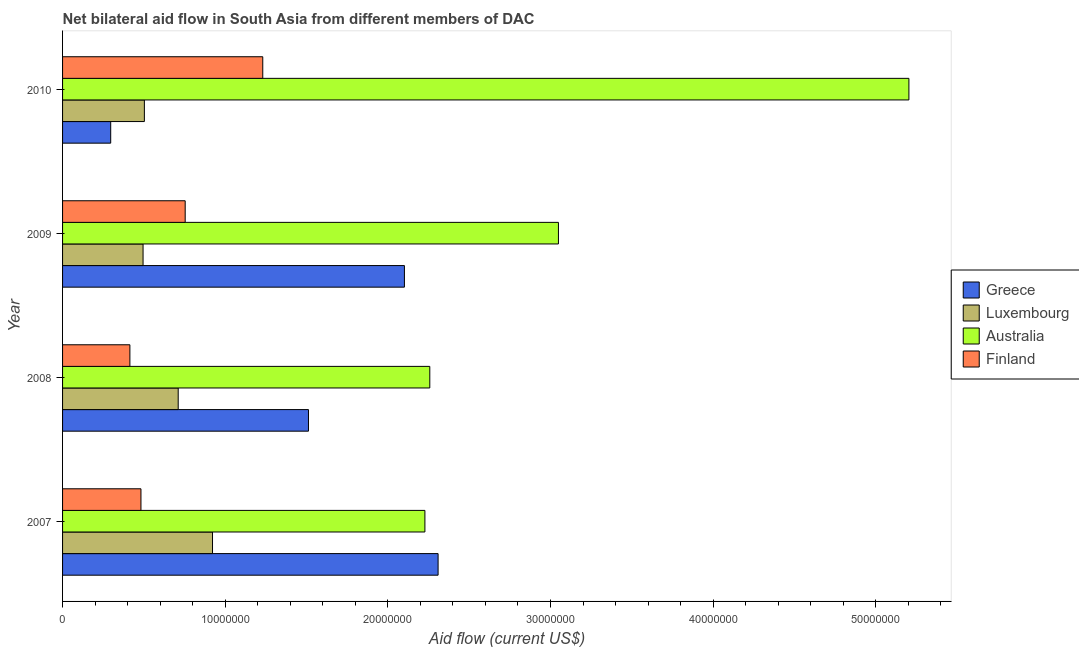How many different coloured bars are there?
Make the answer very short. 4. Are the number of bars per tick equal to the number of legend labels?
Give a very brief answer. Yes. Are the number of bars on each tick of the Y-axis equal?
Ensure brevity in your answer.  Yes. How many bars are there on the 4th tick from the top?
Keep it short and to the point. 4. How many bars are there on the 3rd tick from the bottom?
Give a very brief answer. 4. What is the amount of aid given by australia in 2009?
Provide a short and direct response. 3.05e+07. Across all years, what is the maximum amount of aid given by australia?
Provide a succinct answer. 5.20e+07. Across all years, what is the minimum amount of aid given by finland?
Provide a succinct answer. 4.14e+06. In which year was the amount of aid given by finland minimum?
Provide a succinct answer. 2008. What is the total amount of aid given by finland in the graph?
Offer a very short reply. 2.88e+07. What is the difference between the amount of aid given by greece in 2007 and that in 2009?
Your answer should be compact. 2.07e+06. What is the difference between the amount of aid given by luxembourg in 2010 and the amount of aid given by greece in 2008?
Make the answer very short. -1.01e+07. What is the average amount of aid given by luxembourg per year?
Provide a succinct answer. 6.58e+06. In the year 2007, what is the difference between the amount of aid given by luxembourg and amount of aid given by australia?
Make the answer very short. -1.31e+07. In how many years, is the amount of aid given by luxembourg greater than 20000000 US$?
Give a very brief answer. 0. What is the ratio of the amount of aid given by finland in 2008 to that in 2010?
Your answer should be compact. 0.34. Is the amount of aid given by australia in 2007 less than that in 2010?
Your answer should be very brief. Yes. Is the difference between the amount of aid given by luxembourg in 2008 and 2010 greater than the difference between the amount of aid given by greece in 2008 and 2010?
Provide a succinct answer. No. What is the difference between the highest and the second highest amount of aid given by finland?
Keep it short and to the point. 4.77e+06. What is the difference between the highest and the lowest amount of aid given by australia?
Your answer should be compact. 2.98e+07. In how many years, is the amount of aid given by australia greater than the average amount of aid given by australia taken over all years?
Your answer should be compact. 1. Is it the case that in every year, the sum of the amount of aid given by finland and amount of aid given by luxembourg is greater than the sum of amount of aid given by greece and amount of aid given by australia?
Make the answer very short. No. What does the 2nd bar from the bottom in 2010 represents?
Give a very brief answer. Luxembourg. How many bars are there?
Your response must be concise. 16. Are the values on the major ticks of X-axis written in scientific E-notation?
Your answer should be very brief. No. Does the graph contain any zero values?
Keep it short and to the point. No. Where does the legend appear in the graph?
Ensure brevity in your answer.  Center right. How many legend labels are there?
Your answer should be very brief. 4. How are the legend labels stacked?
Offer a terse response. Vertical. What is the title of the graph?
Offer a very short reply. Net bilateral aid flow in South Asia from different members of DAC. Does "Social Awareness" appear as one of the legend labels in the graph?
Give a very brief answer. No. What is the label or title of the Y-axis?
Your answer should be compact. Year. What is the Aid flow (current US$) of Greece in 2007?
Your answer should be very brief. 2.31e+07. What is the Aid flow (current US$) of Luxembourg in 2007?
Keep it short and to the point. 9.22e+06. What is the Aid flow (current US$) of Australia in 2007?
Offer a terse response. 2.23e+07. What is the Aid flow (current US$) of Finland in 2007?
Your response must be concise. 4.82e+06. What is the Aid flow (current US$) in Greece in 2008?
Your answer should be very brief. 1.51e+07. What is the Aid flow (current US$) in Luxembourg in 2008?
Your answer should be very brief. 7.11e+06. What is the Aid flow (current US$) in Australia in 2008?
Your answer should be very brief. 2.26e+07. What is the Aid flow (current US$) of Finland in 2008?
Give a very brief answer. 4.14e+06. What is the Aid flow (current US$) in Greece in 2009?
Keep it short and to the point. 2.10e+07. What is the Aid flow (current US$) of Luxembourg in 2009?
Make the answer very short. 4.95e+06. What is the Aid flow (current US$) of Australia in 2009?
Ensure brevity in your answer.  3.05e+07. What is the Aid flow (current US$) in Finland in 2009?
Keep it short and to the point. 7.54e+06. What is the Aid flow (current US$) in Greece in 2010?
Keep it short and to the point. 2.96e+06. What is the Aid flow (current US$) in Luxembourg in 2010?
Offer a very short reply. 5.03e+06. What is the Aid flow (current US$) in Australia in 2010?
Your answer should be very brief. 5.20e+07. What is the Aid flow (current US$) in Finland in 2010?
Give a very brief answer. 1.23e+07. Across all years, what is the maximum Aid flow (current US$) in Greece?
Make the answer very short. 2.31e+07. Across all years, what is the maximum Aid flow (current US$) of Luxembourg?
Keep it short and to the point. 9.22e+06. Across all years, what is the maximum Aid flow (current US$) in Australia?
Offer a terse response. 5.20e+07. Across all years, what is the maximum Aid flow (current US$) of Finland?
Ensure brevity in your answer.  1.23e+07. Across all years, what is the minimum Aid flow (current US$) in Greece?
Your answer should be very brief. 2.96e+06. Across all years, what is the minimum Aid flow (current US$) in Luxembourg?
Ensure brevity in your answer.  4.95e+06. Across all years, what is the minimum Aid flow (current US$) in Australia?
Your response must be concise. 2.23e+07. Across all years, what is the minimum Aid flow (current US$) in Finland?
Your answer should be compact. 4.14e+06. What is the total Aid flow (current US$) in Greece in the graph?
Keep it short and to the point. 6.22e+07. What is the total Aid flow (current US$) of Luxembourg in the graph?
Your answer should be very brief. 2.63e+07. What is the total Aid flow (current US$) in Australia in the graph?
Your answer should be compact. 1.27e+08. What is the total Aid flow (current US$) in Finland in the graph?
Provide a short and direct response. 2.88e+07. What is the difference between the Aid flow (current US$) in Greece in 2007 and that in 2008?
Ensure brevity in your answer.  7.97e+06. What is the difference between the Aid flow (current US$) of Luxembourg in 2007 and that in 2008?
Your response must be concise. 2.11e+06. What is the difference between the Aid flow (current US$) of Australia in 2007 and that in 2008?
Give a very brief answer. -3.00e+05. What is the difference between the Aid flow (current US$) in Finland in 2007 and that in 2008?
Make the answer very short. 6.80e+05. What is the difference between the Aid flow (current US$) in Greece in 2007 and that in 2009?
Make the answer very short. 2.07e+06. What is the difference between the Aid flow (current US$) of Luxembourg in 2007 and that in 2009?
Your answer should be very brief. 4.27e+06. What is the difference between the Aid flow (current US$) of Australia in 2007 and that in 2009?
Keep it short and to the point. -8.21e+06. What is the difference between the Aid flow (current US$) in Finland in 2007 and that in 2009?
Provide a short and direct response. -2.72e+06. What is the difference between the Aid flow (current US$) of Greece in 2007 and that in 2010?
Your response must be concise. 2.01e+07. What is the difference between the Aid flow (current US$) of Luxembourg in 2007 and that in 2010?
Your response must be concise. 4.19e+06. What is the difference between the Aid flow (current US$) of Australia in 2007 and that in 2010?
Provide a short and direct response. -2.98e+07. What is the difference between the Aid flow (current US$) of Finland in 2007 and that in 2010?
Your answer should be very brief. -7.49e+06. What is the difference between the Aid flow (current US$) of Greece in 2008 and that in 2009?
Your response must be concise. -5.90e+06. What is the difference between the Aid flow (current US$) of Luxembourg in 2008 and that in 2009?
Give a very brief answer. 2.16e+06. What is the difference between the Aid flow (current US$) in Australia in 2008 and that in 2009?
Offer a terse response. -7.91e+06. What is the difference between the Aid flow (current US$) of Finland in 2008 and that in 2009?
Keep it short and to the point. -3.40e+06. What is the difference between the Aid flow (current US$) of Greece in 2008 and that in 2010?
Offer a terse response. 1.22e+07. What is the difference between the Aid flow (current US$) in Luxembourg in 2008 and that in 2010?
Ensure brevity in your answer.  2.08e+06. What is the difference between the Aid flow (current US$) of Australia in 2008 and that in 2010?
Offer a very short reply. -2.95e+07. What is the difference between the Aid flow (current US$) of Finland in 2008 and that in 2010?
Your answer should be compact. -8.17e+06. What is the difference between the Aid flow (current US$) in Greece in 2009 and that in 2010?
Give a very brief answer. 1.81e+07. What is the difference between the Aid flow (current US$) of Australia in 2009 and that in 2010?
Your answer should be compact. -2.16e+07. What is the difference between the Aid flow (current US$) in Finland in 2009 and that in 2010?
Give a very brief answer. -4.77e+06. What is the difference between the Aid flow (current US$) in Greece in 2007 and the Aid flow (current US$) in Luxembourg in 2008?
Provide a short and direct response. 1.60e+07. What is the difference between the Aid flow (current US$) of Greece in 2007 and the Aid flow (current US$) of Australia in 2008?
Offer a very short reply. 5.10e+05. What is the difference between the Aid flow (current US$) in Greece in 2007 and the Aid flow (current US$) in Finland in 2008?
Keep it short and to the point. 1.90e+07. What is the difference between the Aid flow (current US$) in Luxembourg in 2007 and the Aid flow (current US$) in Australia in 2008?
Keep it short and to the point. -1.34e+07. What is the difference between the Aid flow (current US$) of Luxembourg in 2007 and the Aid flow (current US$) of Finland in 2008?
Make the answer very short. 5.08e+06. What is the difference between the Aid flow (current US$) in Australia in 2007 and the Aid flow (current US$) in Finland in 2008?
Your response must be concise. 1.81e+07. What is the difference between the Aid flow (current US$) in Greece in 2007 and the Aid flow (current US$) in Luxembourg in 2009?
Give a very brief answer. 1.81e+07. What is the difference between the Aid flow (current US$) of Greece in 2007 and the Aid flow (current US$) of Australia in 2009?
Give a very brief answer. -7.40e+06. What is the difference between the Aid flow (current US$) of Greece in 2007 and the Aid flow (current US$) of Finland in 2009?
Offer a very short reply. 1.56e+07. What is the difference between the Aid flow (current US$) of Luxembourg in 2007 and the Aid flow (current US$) of Australia in 2009?
Your answer should be very brief. -2.13e+07. What is the difference between the Aid flow (current US$) of Luxembourg in 2007 and the Aid flow (current US$) of Finland in 2009?
Your response must be concise. 1.68e+06. What is the difference between the Aid flow (current US$) in Australia in 2007 and the Aid flow (current US$) in Finland in 2009?
Your answer should be compact. 1.47e+07. What is the difference between the Aid flow (current US$) in Greece in 2007 and the Aid flow (current US$) in Luxembourg in 2010?
Give a very brief answer. 1.81e+07. What is the difference between the Aid flow (current US$) of Greece in 2007 and the Aid flow (current US$) of Australia in 2010?
Provide a short and direct response. -2.90e+07. What is the difference between the Aid flow (current US$) of Greece in 2007 and the Aid flow (current US$) of Finland in 2010?
Ensure brevity in your answer.  1.08e+07. What is the difference between the Aid flow (current US$) in Luxembourg in 2007 and the Aid flow (current US$) in Australia in 2010?
Provide a succinct answer. -4.28e+07. What is the difference between the Aid flow (current US$) of Luxembourg in 2007 and the Aid flow (current US$) of Finland in 2010?
Provide a succinct answer. -3.09e+06. What is the difference between the Aid flow (current US$) in Australia in 2007 and the Aid flow (current US$) in Finland in 2010?
Offer a terse response. 9.97e+06. What is the difference between the Aid flow (current US$) of Greece in 2008 and the Aid flow (current US$) of Luxembourg in 2009?
Keep it short and to the point. 1.02e+07. What is the difference between the Aid flow (current US$) in Greece in 2008 and the Aid flow (current US$) in Australia in 2009?
Offer a very short reply. -1.54e+07. What is the difference between the Aid flow (current US$) of Greece in 2008 and the Aid flow (current US$) of Finland in 2009?
Ensure brevity in your answer.  7.58e+06. What is the difference between the Aid flow (current US$) in Luxembourg in 2008 and the Aid flow (current US$) in Australia in 2009?
Ensure brevity in your answer.  -2.34e+07. What is the difference between the Aid flow (current US$) of Luxembourg in 2008 and the Aid flow (current US$) of Finland in 2009?
Give a very brief answer. -4.30e+05. What is the difference between the Aid flow (current US$) of Australia in 2008 and the Aid flow (current US$) of Finland in 2009?
Give a very brief answer. 1.50e+07. What is the difference between the Aid flow (current US$) of Greece in 2008 and the Aid flow (current US$) of Luxembourg in 2010?
Keep it short and to the point. 1.01e+07. What is the difference between the Aid flow (current US$) of Greece in 2008 and the Aid flow (current US$) of Australia in 2010?
Ensure brevity in your answer.  -3.69e+07. What is the difference between the Aid flow (current US$) in Greece in 2008 and the Aid flow (current US$) in Finland in 2010?
Offer a very short reply. 2.81e+06. What is the difference between the Aid flow (current US$) of Luxembourg in 2008 and the Aid flow (current US$) of Australia in 2010?
Give a very brief answer. -4.49e+07. What is the difference between the Aid flow (current US$) of Luxembourg in 2008 and the Aid flow (current US$) of Finland in 2010?
Your answer should be compact. -5.20e+06. What is the difference between the Aid flow (current US$) in Australia in 2008 and the Aid flow (current US$) in Finland in 2010?
Provide a succinct answer. 1.03e+07. What is the difference between the Aid flow (current US$) in Greece in 2009 and the Aid flow (current US$) in Luxembourg in 2010?
Provide a succinct answer. 1.60e+07. What is the difference between the Aid flow (current US$) in Greece in 2009 and the Aid flow (current US$) in Australia in 2010?
Offer a terse response. -3.10e+07. What is the difference between the Aid flow (current US$) of Greece in 2009 and the Aid flow (current US$) of Finland in 2010?
Provide a succinct answer. 8.71e+06. What is the difference between the Aid flow (current US$) of Luxembourg in 2009 and the Aid flow (current US$) of Australia in 2010?
Ensure brevity in your answer.  -4.71e+07. What is the difference between the Aid flow (current US$) of Luxembourg in 2009 and the Aid flow (current US$) of Finland in 2010?
Your answer should be very brief. -7.36e+06. What is the difference between the Aid flow (current US$) in Australia in 2009 and the Aid flow (current US$) in Finland in 2010?
Your answer should be very brief. 1.82e+07. What is the average Aid flow (current US$) in Greece per year?
Keep it short and to the point. 1.55e+07. What is the average Aid flow (current US$) in Luxembourg per year?
Give a very brief answer. 6.58e+06. What is the average Aid flow (current US$) in Australia per year?
Your response must be concise. 3.18e+07. What is the average Aid flow (current US$) in Finland per year?
Give a very brief answer. 7.20e+06. In the year 2007, what is the difference between the Aid flow (current US$) of Greece and Aid flow (current US$) of Luxembourg?
Give a very brief answer. 1.39e+07. In the year 2007, what is the difference between the Aid flow (current US$) of Greece and Aid flow (current US$) of Australia?
Offer a terse response. 8.10e+05. In the year 2007, what is the difference between the Aid flow (current US$) of Greece and Aid flow (current US$) of Finland?
Offer a very short reply. 1.83e+07. In the year 2007, what is the difference between the Aid flow (current US$) of Luxembourg and Aid flow (current US$) of Australia?
Your answer should be compact. -1.31e+07. In the year 2007, what is the difference between the Aid flow (current US$) in Luxembourg and Aid flow (current US$) in Finland?
Offer a terse response. 4.40e+06. In the year 2007, what is the difference between the Aid flow (current US$) in Australia and Aid flow (current US$) in Finland?
Give a very brief answer. 1.75e+07. In the year 2008, what is the difference between the Aid flow (current US$) of Greece and Aid flow (current US$) of Luxembourg?
Your response must be concise. 8.01e+06. In the year 2008, what is the difference between the Aid flow (current US$) in Greece and Aid flow (current US$) in Australia?
Provide a succinct answer. -7.46e+06. In the year 2008, what is the difference between the Aid flow (current US$) of Greece and Aid flow (current US$) of Finland?
Your answer should be compact. 1.10e+07. In the year 2008, what is the difference between the Aid flow (current US$) of Luxembourg and Aid flow (current US$) of Australia?
Keep it short and to the point. -1.55e+07. In the year 2008, what is the difference between the Aid flow (current US$) of Luxembourg and Aid flow (current US$) of Finland?
Your answer should be compact. 2.97e+06. In the year 2008, what is the difference between the Aid flow (current US$) of Australia and Aid flow (current US$) of Finland?
Give a very brief answer. 1.84e+07. In the year 2009, what is the difference between the Aid flow (current US$) of Greece and Aid flow (current US$) of Luxembourg?
Make the answer very short. 1.61e+07. In the year 2009, what is the difference between the Aid flow (current US$) of Greece and Aid flow (current US$) of Australia?
Provide a succinct answer. -9.47e+06. In the year 2009, what is the difference between the Aid flow (current US$) in Greece and Aid flow (current US$) in Finland?
Your answer should be very brief. 1.35e+07. In the year 2009, what is the difference between the Aid flow (current US$) in Luxembourg and Aid flow (current US$) in Australia?
Offer a terse response. -2.55e+07. In the year 2009, what is the difference between the Aid flow (current US$) in Luxembourg and Aid flow (current US$) in Finland?
Offer a very short reply. -2.59e+06. In the year 2009, what is the difference between the Aid flow (current US$) of Australia and Aid flow (current US$) of Finland?
Offer a terse response. 2.30e+07. In the year 2010, what is the difference between the Aid flow (current US$) in Greece and Aid flow (current US$) in Luxembourg?
Provide a succinct answer. -2.07e+06. In the year 2010, what is the difference between the Aid flow (current US$) of Greece and Aid flow (current US$) of Australia?
Offer a very short reply. -4.91e+07. In the year 2010, what is the difference between the Aid flow (current US$) in Greece and Aid flow (current US$) in Finland?
Provide a succinct answer. -9.35e+06. In the year 2010, what is the difference between the Aid flow (current US$) of Luxembourg and Aid flow (current US$) of Australia?
Your response must be concise. -4.70e+07. In the year 2010, what is the difference between the Aid flow (current US$) of Luxembourg and Aid flow (current US$) of Finland?
Your answer should be very brief. -7.28e+06. In the year 2010, what is the difference between the Aid flow (current US$) of Australia and Aid flow (current US$) of Finland?
Your answer should be very brief. 3.97e+07. What is the ratio of the Aid flow (current US$) in Greece in 2007 to that in 2008?
Your answer should be compact. 1.53. What is the ratio of the Aid flow (current US$) in Luxembourg in 2007 to that in 2008?
Provide a succinct answer. 1.3. What is the ratio of the Aid flow (current US$) in Australia in 2007 to that in 2008?
Provide a succinct answer. 0.99. What is the ratio of the Aid flow (current US$) in Finland in 2007 to that in 2008?
Give a very brief answer. 1.16. What is the ratio of the Aid flow (current US$) in Greece in 2007 to that in 2009?
Give a very brief answer. 1.1. What is the ratio of the Aid flow (current US$) of Luxembourg in 2007 to that in 2009?
Give a very brief answer. 1.86. What is the ratio of the Aid flow (current US$) in Australia in 2007 to that in 2009?
Offer a very short reply. 0.73. What is the ratio of the Aid flow (current US$) in Finland in 2007 to that in 2009?
Provide a succinct answer. 0.64. What is the ratio of the Aid flow (current US$) of Greece in 2007 to that in 2010?
Provide a succinct answer. 7.8. What is the ratio of the Aid flow (current US$) of Luxembourg in 2007 to that in 2010?
Provide a succinct answer. 1.83. What is the ratio of the Aid flow (current US$) of Australia in 2007 to that in 2010?
Keep it short and to the point. 0.43. What is the ratio of the Aid flow (current US$) of Finland in 2007 to that in 2010?
Make the answer very short. 0.39. What is the ratio of the Aid flow (current US$) in Greece in 2008 to that in 2009?
Ensure brevity in your answer.  0.72. What is the ratio of the Aid flow (current US$) of Luxembourg in 2008 to that in 2009?
Provide a succinct answer. 1.44. What is the ratio of the Aid flow (current US$) of Australia in 2008 to that in 2009?
Provide a succinct answer. 0.74. What is the ratio of the Aid flow (current US$) in Finland in 2008 to that in 2009?
Your response must be concise. 0.55. What is the ratio of the Aid flow (current US$) of Greece in 2008 to that in 2010?
Your response must be concise. 5.11. What is the ratio of the Aid flow (current US$) of Luxembourg in 2008 to that in 2010?
Offer a very short reply. 1.41. What is the ratio of the Aid flow (current US$) of Australia in 2008 to that in 2010?
Keep it short and to the point. 0.43. What is the ratio of the Aid flow (current US$) in Finland in 2008 to that in 2010?
Ensure brevity in your answer.  0.34. What is the ratio of the Aid flow (current US$) of Greece in 2009 to that in 2010?
Your answer should be compact. 7.1. What is the ratio of the Aid flow (current US$) in Luxembourg in 2009 to that in 2010?
Offer a terse response. 0.98. What is the ratio of the Aid flow (current US$) in Australia in 2009 to that in 2010?
Offer a terse response. 0.59. What is the ratio of the Aid flow (current US$) in Finland in 2009 to that in 2010?
Your answer should be compact. 0.61. What is the difference between the highest and the second highest Aid flow (current US$) in Greece?
Offer a terse response. 2.07e+06. What is the difference between the highest and the second highest Aid flow (current US$) in Luxembourg?
Your answer should be very brief. 2.11e+06. What is the difference between the highest and the second highest Aid flow (current US$) in Australia?
Offer a very short reply. 2.16e+07. What is the difference between the highest and the second highest Aid flow (current US$) of Finland?
Offer a terse response. 4.77e+06. What is the difference between the highest and the lowest Aid flow (current US$) of Greece?
Ensure brevity in your answer.  2.01e+07. What is the difference between the highest and the lowest Aid flow (current US$) of Luxembourg?
Provide a short and direct response. 4.27e+06. What is the difference between the highest and the lowest Aid flow (current US$) in Australia?
Keep it short and to the point. 2.98e+07. What is the difference between the highest and the lowest Aid flow (current US$) in Finland?
Offer a very short reply. 8.17e+06. 